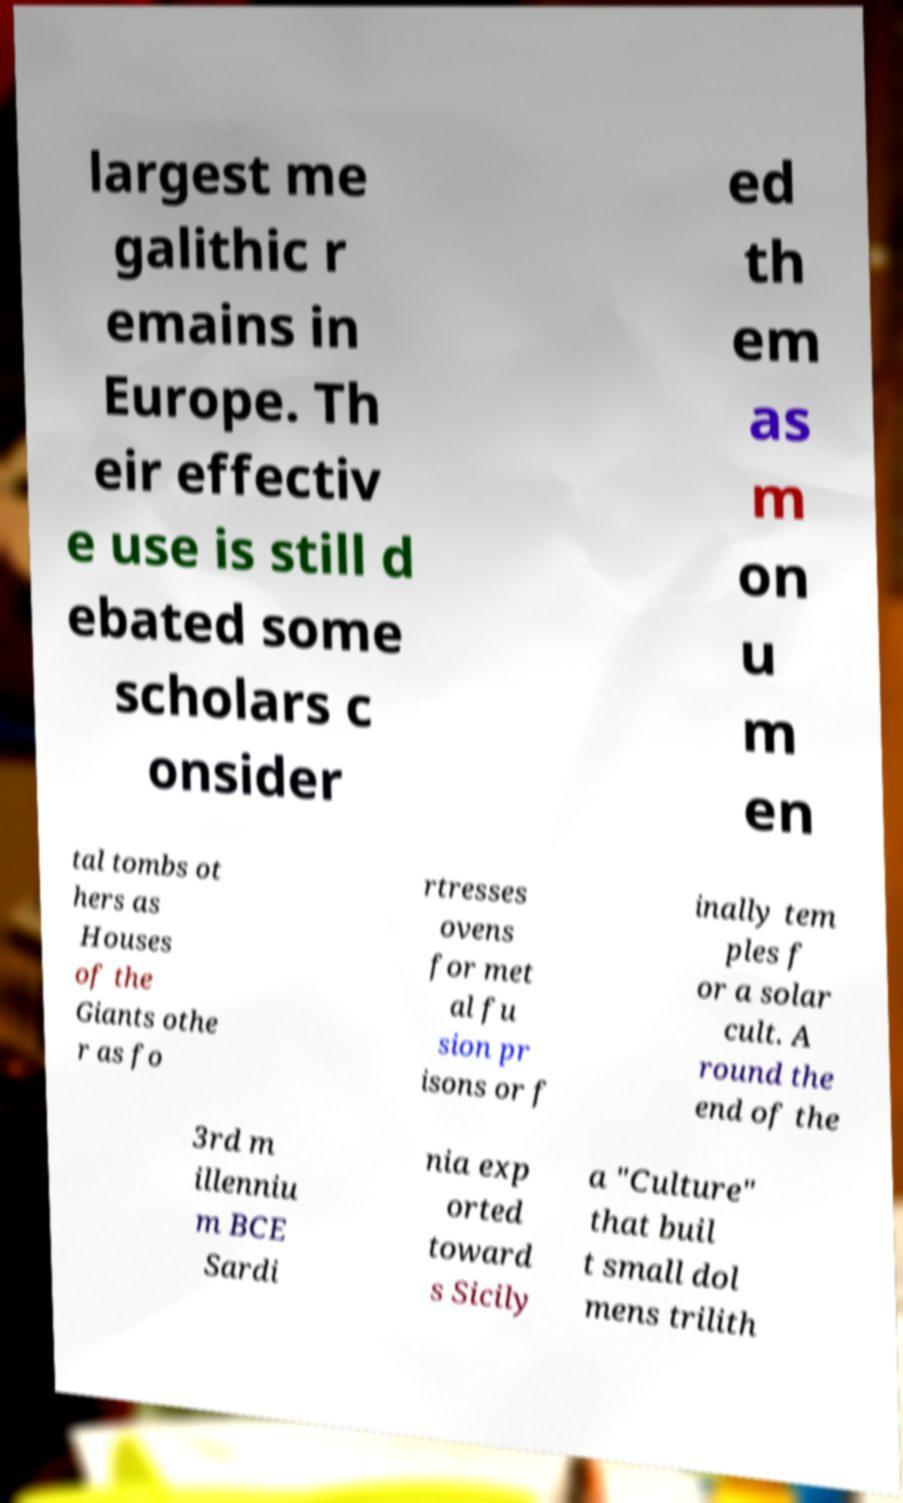I need the written content from this picture converted into text. Can you do that? largest me galithic r emains in Europe. Th eir effectiv e use is still d ebated some scholars c onsider ed th em as m on u m en tal tombs ot hers as Houses of the Giants othe r as fo rtresses ovens for met al fu sion pr isons or f inally tem ples f or a solar cult. A round the end of the 3rd m illenniu m BCE Sardi nia exp orted toward s Sicily a "Culture" that buil t small dol mens trilith 